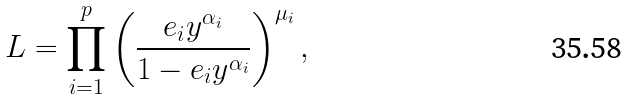<formula> <loc_0><loc_0><loc_500><loc_500>L = \prod _ { i = 1 } ^ { p } \left ( \frac { e _ { i } y ^ { \alpha _ { i } } } { 1 - e _ { i } y ^ { \alpha _ { i } } } \right ) ^ { \mu _ { i } } ,</formula> 